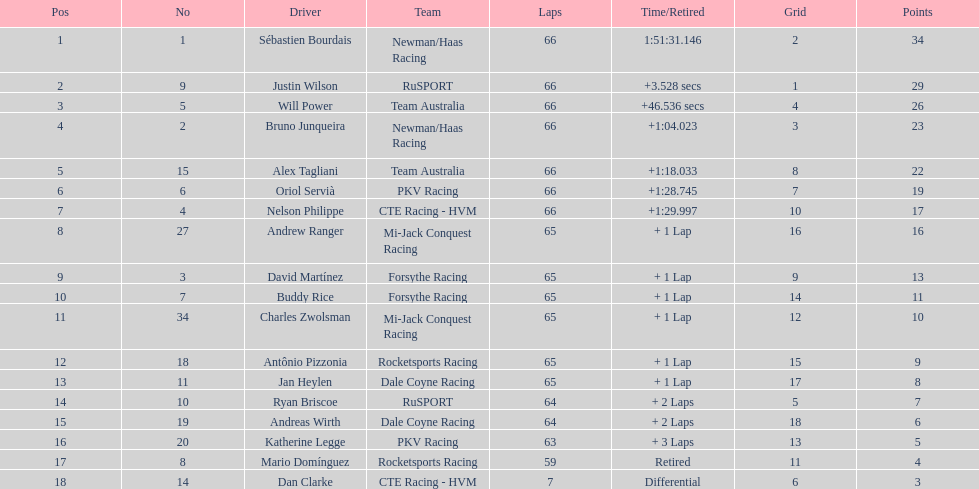Which driver has the same number as his/her position? Sébastien Bourdais. 